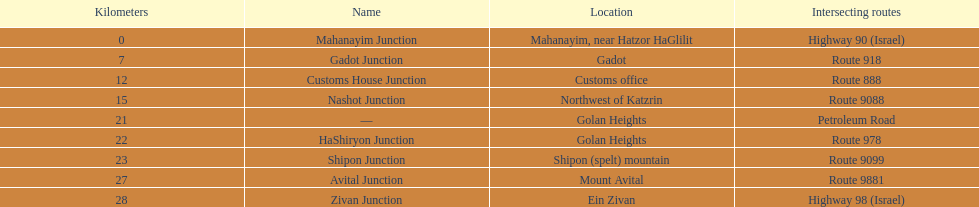Which intersections intersect a path? Gadot Junction, Customs House Junction, Nashot Junction, HaShiryon Junction, Shipon Junction, Avital Junction. Which of these has a portion of its name in common with its location's name? Gadot Junction, Customs House Junction, Shipon Junction, Avital Junction. Which of them is not situated in a place named after a mountain? Gadot Junction, Customs House Junction. Which of these possesses the greatest route number? Gadot Junction. 